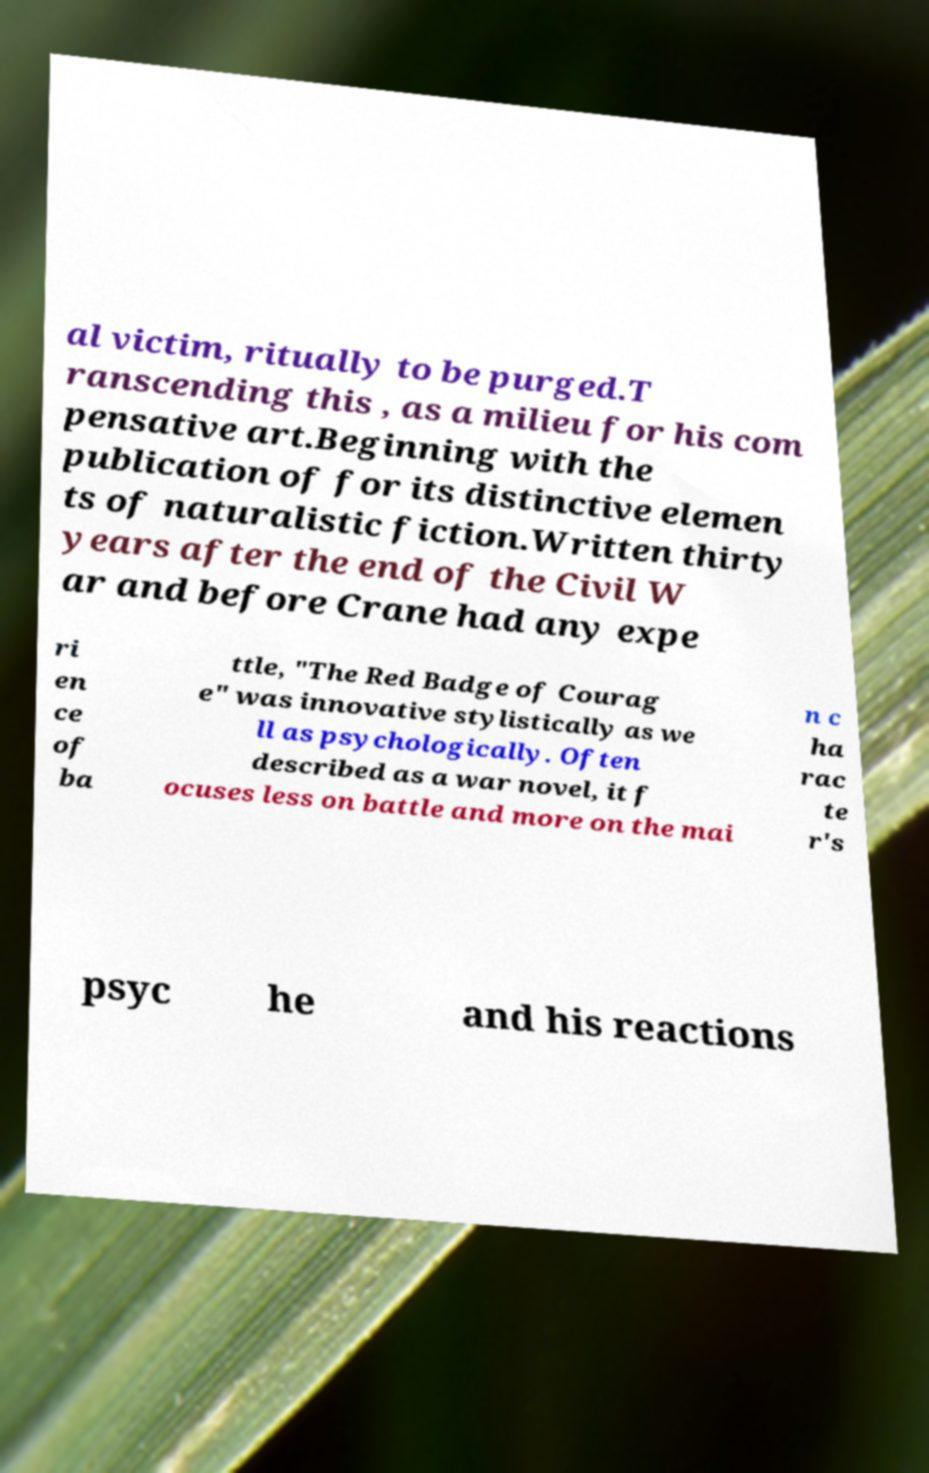Can you read and provide the text displayed in the image?This photo seems to have some interesting text. Can you extract and type it out for me? al victim, ritually to be purged.T ranscending this , as a milieu for his com pensative art.Beginning with the publication of for its distinctive elemen ts of naturalistic fiction.Written thirty years after the end of the Civil W ar and before Crane had any expe ri en ce of ba ttle, "The Red Badge of Courag e" was innovative stylistically as we ll as psychologically. Often described as a war novel, it f ocuses less on battle and more on the mai n c ha rac te r's psyc he and his reactions 